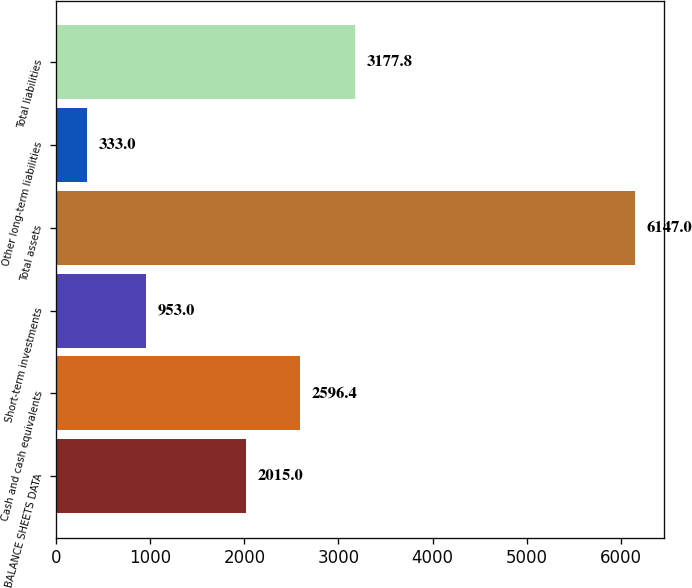Convert chart. <chart><loc_0><loc_0><loc_500><loc_500><bar_chart><fcel>BALANCE SHEETS DATA<fcel>Cash and cash equivalents<fcel>Short-term investments<fcel>Total assets<fcel>Other long-term liabilities<fcel>Total liabilities<nl><fcel>2015<fcel>2596.4<fcel>953<fcel>6147<fcel>333<fcel>3177.8<nl></chart> 